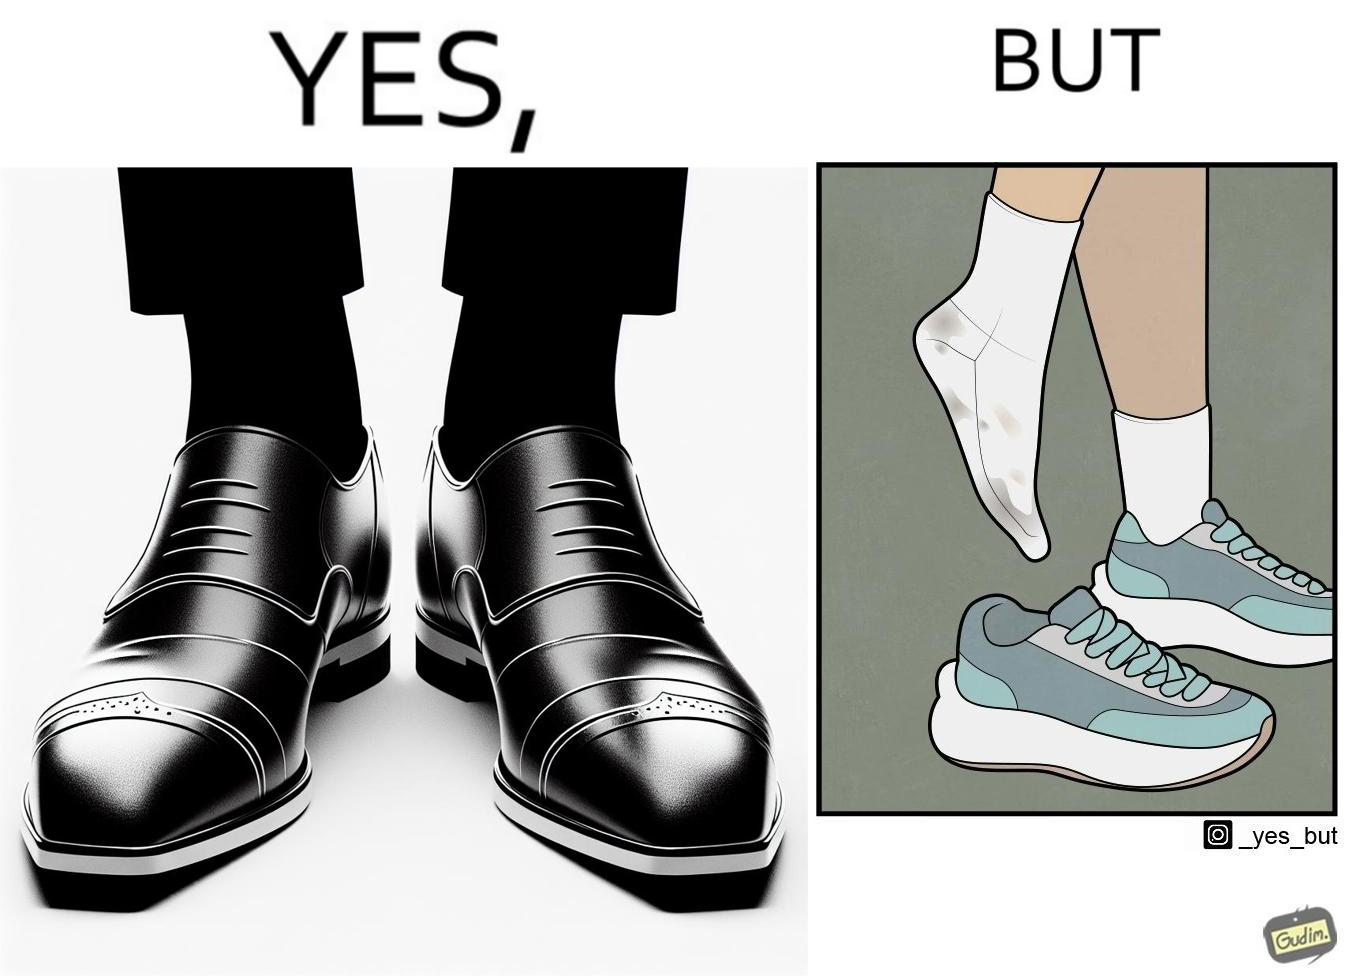Describe the contrast between the left and right parts of this image. In the left part of the image: The image is showing neat and clean shoes. In the right part of the image: The image is showing dirty shocks. 